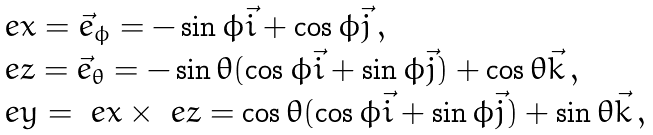Convert formula to latex. <formula><loc_0><loc_0><loc_500><loc_500>\begin{array} { l } \ e x = \vec { e } _ { \phi } = - \sin \phi \vec { i } + \cos \phi \vec { j } \, , \\ \ e z = \vec { e } _ { \theta } = - \sin \theta ( \cos \phi \vec { i } + \sin \phi \vec { j } ) + \cos \theta \vec { k } \, , \\ \ e y = \ e x \times \ e z = \cos \theta ( \cos \phi \vec { i } + \sin \phi \vec { j } ) + \sin \theta \vec { k } \, , \end{array}</formula> 